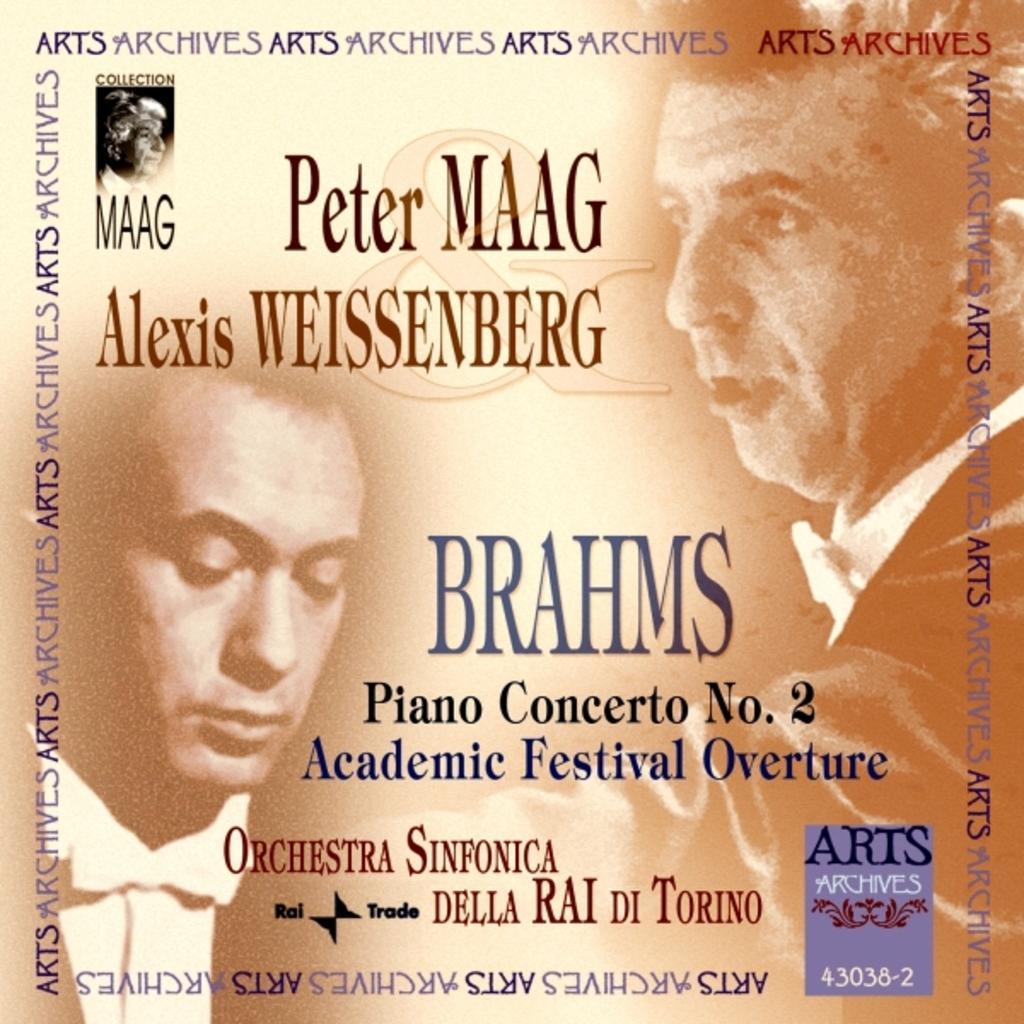Describe this image in one or two sentences. In this image there are personś printed, there is text printed. 